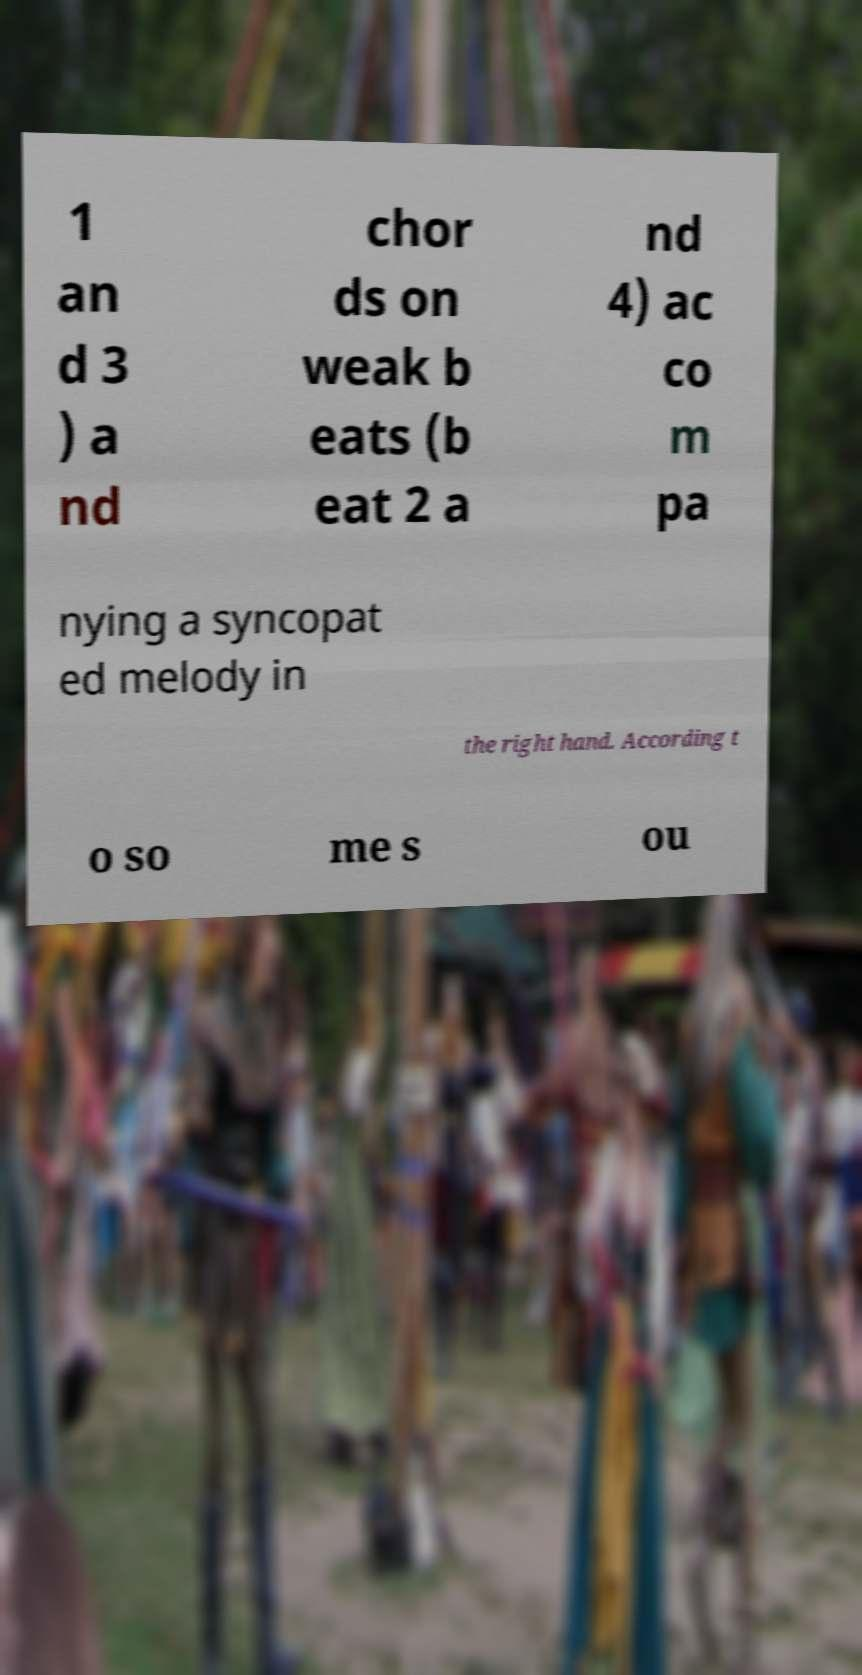What messages or text are displayed in this image? I need them in a readable, typed format. 1 an d 3 ) a nd chor ds on weak b eats (b eat 2 a nd 4) ac co m pa nying a syncopat ed melody in the right hand. According t o so me s ou 